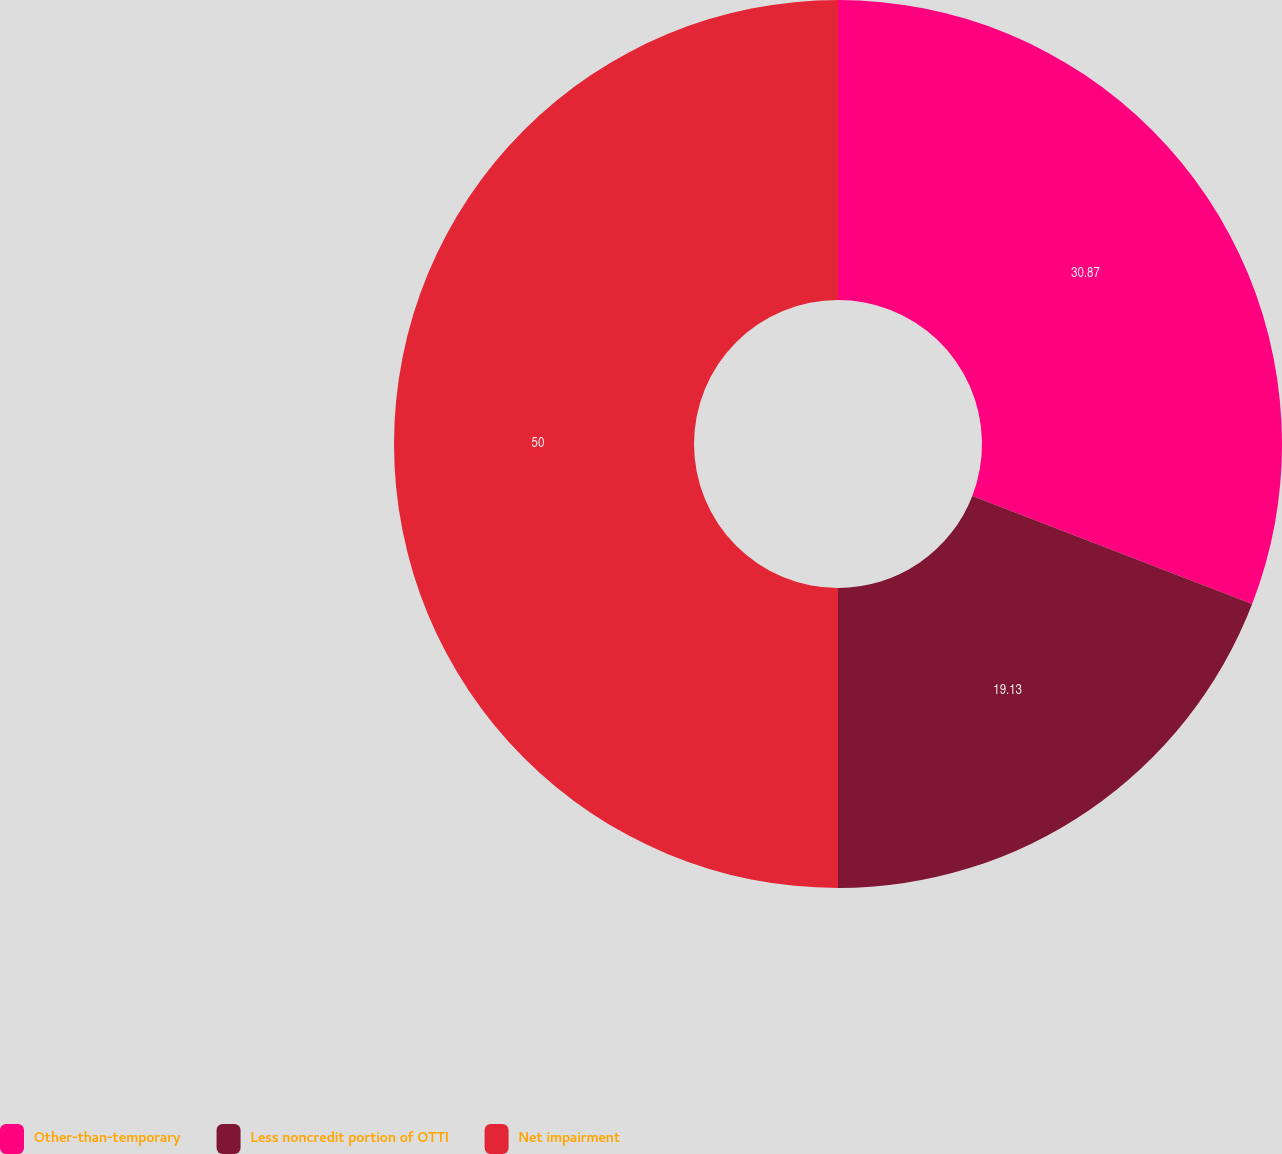Convert chart to OTSL. <chart><loc_0><loc_0><loc_500><loc_500><pie_chart><fcel>Other-than-temporary<fcel>Less noncredit portion of OTTI<fcel>Net impairment<nl><fcel>30.87%<fcel>19.13%<fcel>50.0%<nl></chart> 